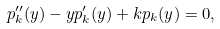Convert formula to latex. <formula><loc_0><loc_0><loc_500><loc_500>p _ { k } ^ { \prime \prime } ( y ) - y p _ { k } ^ { \prime } ( y ) + k p _ { k } ( y ) = 0 ,</formula> 